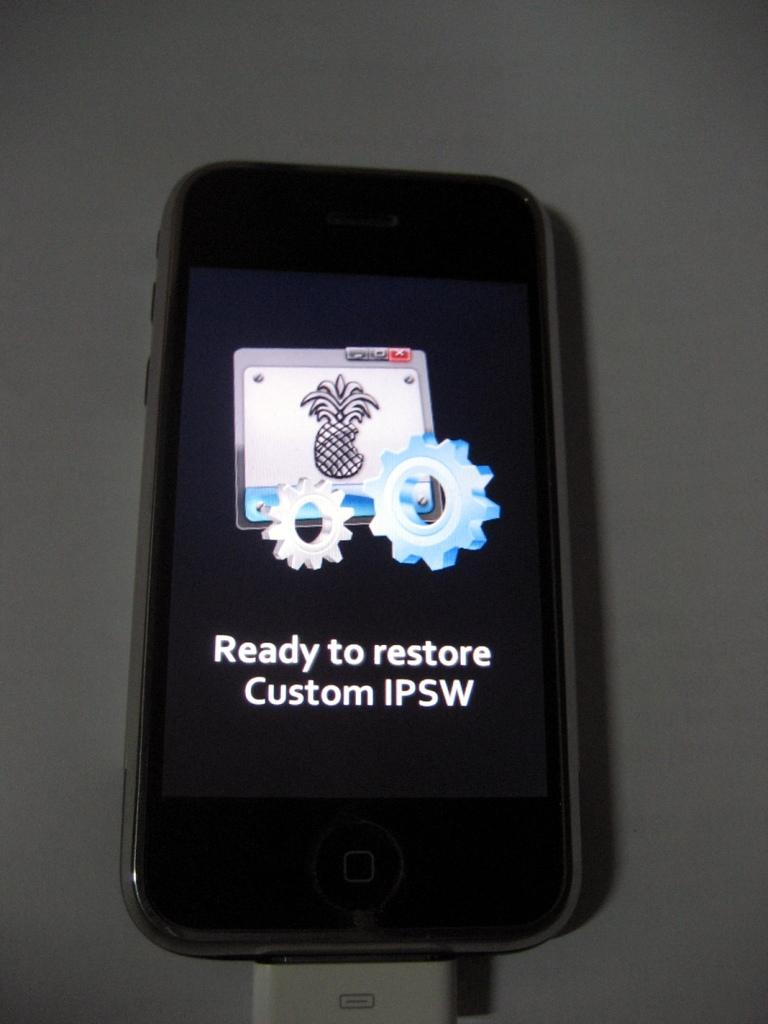What is the main object in the image? There is a mobile in the image. Where is the mobile located? The mobile is on a platform. Is there anything connected to the mobile? Yes, there is a cable attached to the mobile. What type of worm can be seen crawling on the mobile in the image? There is no worm present in the image; it only features a mobile on a platform with a cable attached. 